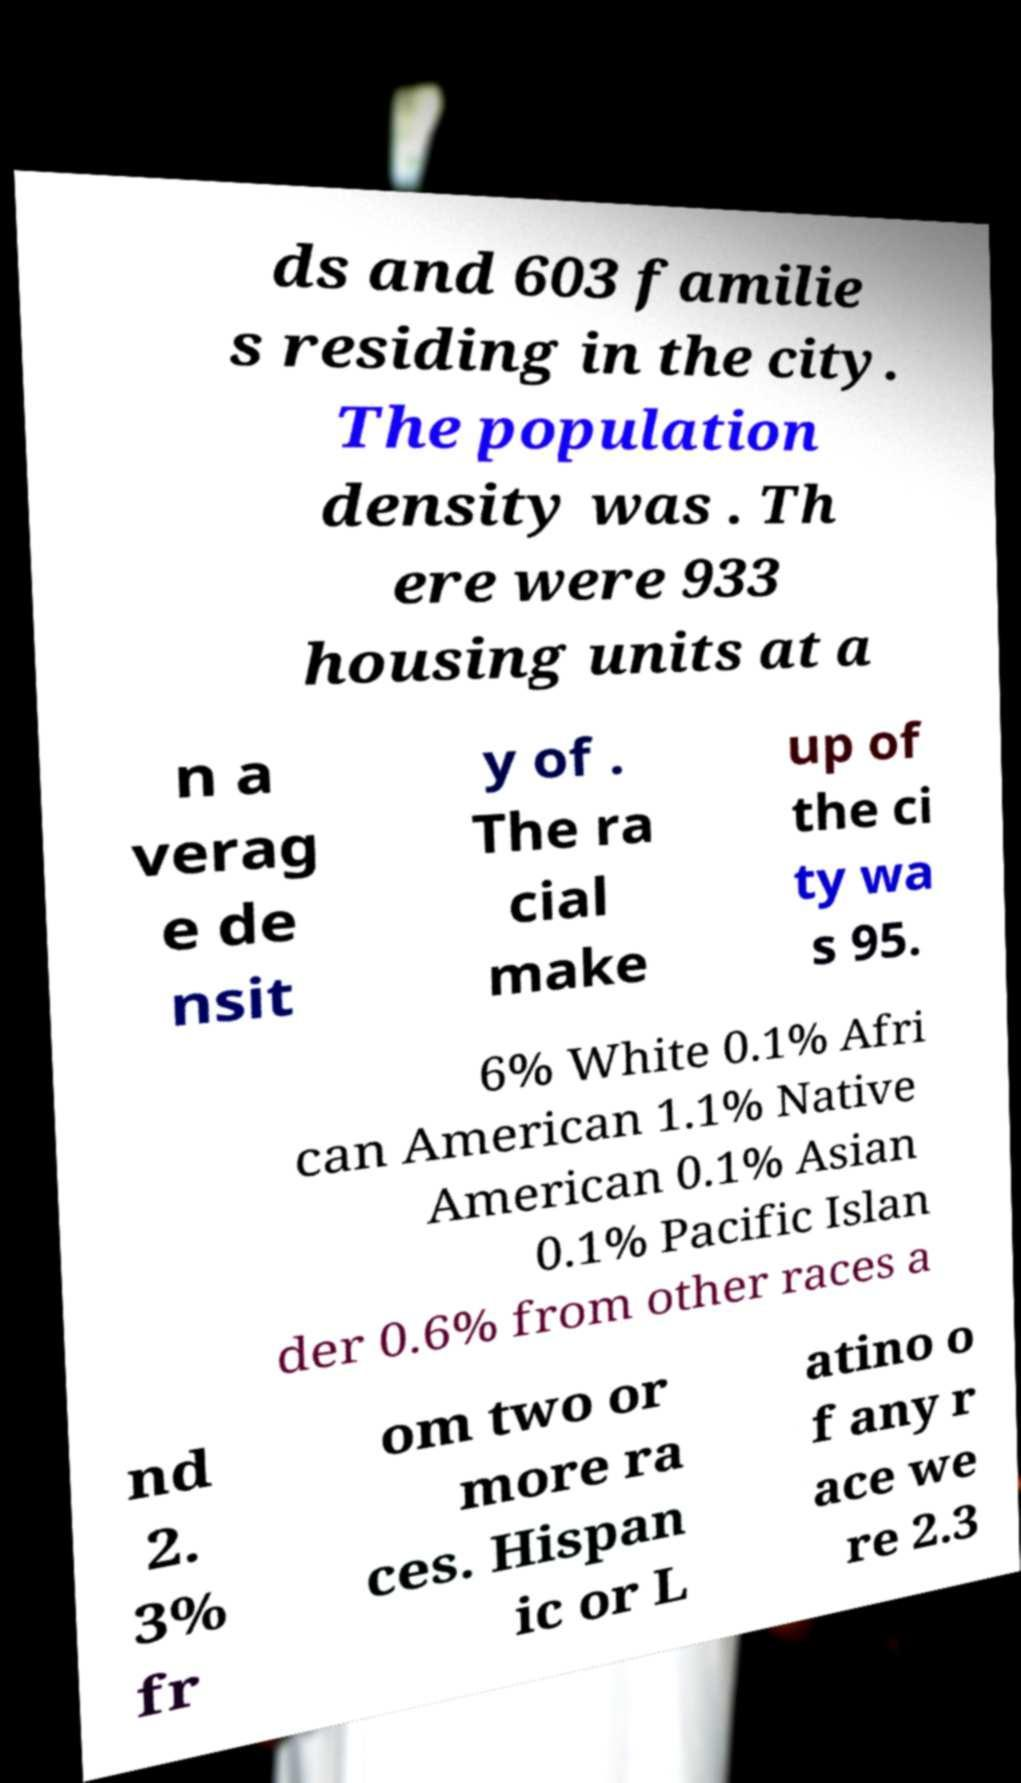Please read and relay the text visible in this image. What does it say? ds and 603 familie s residing in the city. The population density was . Th ere were 933 housing units at a n a verag e de nsit y of . The ra cial make up of the ci ty wa s 95. 6% White 0.1% Afri can American 1.1% Native American 0.1% Asian 0.1% Pacific Islan der 0.6% from other races a nd 2. 3% fr om two or more ra ces. Hispan ic or L atino o f any r ace we re 2.3 